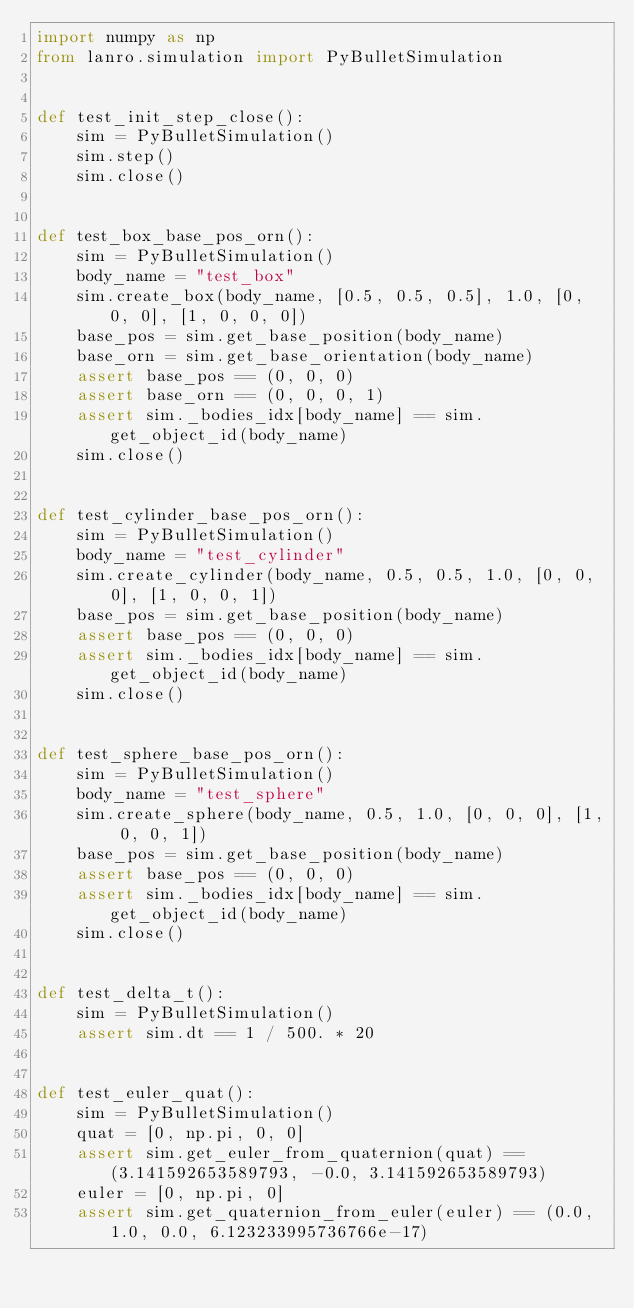Convert code to text. <code><loc_0><loc_0><loc_500><loc_500><_Python_>import numpy as np
from lanro.simulation import PyBulletSimulation


def test_init_step_close():
    sim = PyBulletSimulation()
    sim.step()
    sim.close()


def test_box_base_pos_orn():
    sim = PyBulletSimulation()
    body_name = "test_box"
    sim.create_box(body_name, [0.5, 0.5, 0.5], 1.0, [0, 0, 0], [1, 0, 0, 0])
    base_pos = sim.get_base_position(body_name)
    base_orn = sim.get_base_orientation(body_name)
    assert base_pos == (0, 0, 0)
    assert base_orn == (0, 0, 0, 1)
    assert sim._bodies_idx[body_name] == sim.get_object_id(body_name)
    sim.close()


def test_cylinder_base_pos_orn():
    sim = PyBulletSimulation()
    body_name = "test_cylinder"
    sim.create_cylinder(body_name, 0.5, 0.5, 1.0, [0, 0, 0], [1, 0, 0, 1])
    base_pos = sim.get_base_position(body_name)
    assert base_pos == (0, 0, 0)
    assert sim._bodies_idx[body_name] == sim.get_object_id(body_name)
    sim.close()


def test_sphere_base_pos_orn():
    sim = PyBulletSimulation()
    body_name = "test_sphere"
    sim.create_sphere(body_name, 0.5, 1.0, [0, 0, 0], [1, 0, 0, 1])
    base_pos = sim.get_base_position(body_name)
    assert base_pos == (0, 0, 0)
    assert sim._bodies_idx[body_name] == sim.get_object_id(body_name)
    sim.close()


def test_delta_t():
    sim = PyBulletSimulation()
    assert sim.dt == 1 / 500. * 20


def test_euler_quat():
    sim = PyBulletSimulation()
    quat = [0, np.pi, 0, 0]
    assert sim.get_euler_from_quaternion(quat) == (3.141592653589793, -0.0, 3.141592653589793)
    euler = [0, np.pi, 0]
    assert sim.get_quaternion_from_euler(euler) == (0.0, 1.0, 0.0, 6.123233995736766e-17)
</code> 